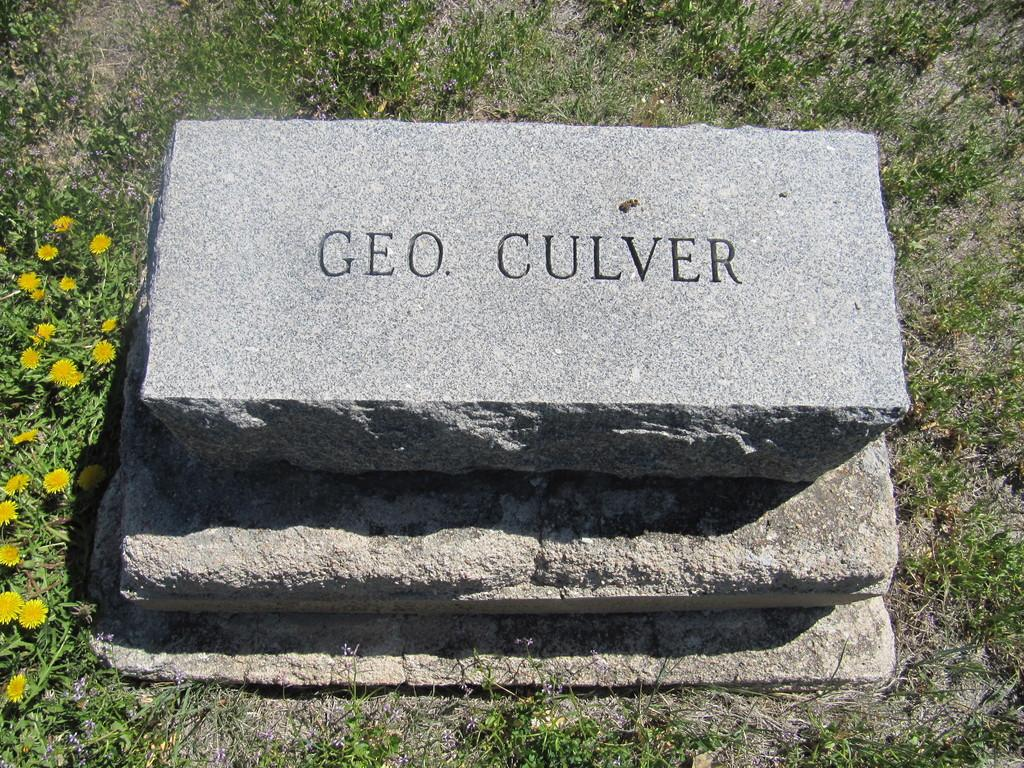What is the main subject in the middle of the image? There is a rock in the middle of the image. What is written or depicted on the rock? There is text on the rock. What type of vegetation surrounds the rock? There is grass around the rock. What type of plants can be seen on the left side of the image? There are plants with flowers on the left side of the image. Can you see a wren flying in a circle around the stream in the image? There is no wren or stream present in the image. 